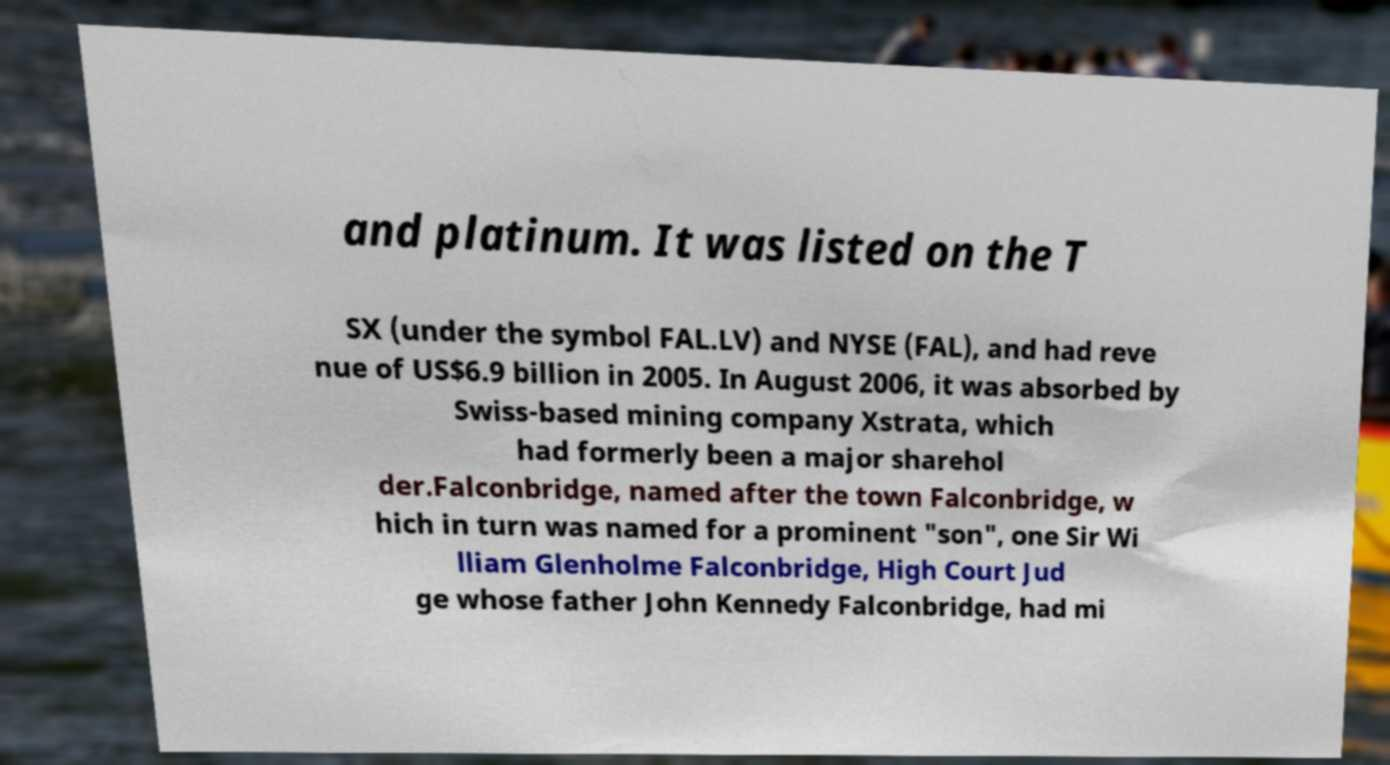Can you read and provide the text displayed in the image?This photo seems to have some interesting text. Can you extract and type it out for me? and platinum. It was listed on the T SX (under the symbol FAL.LV) and NYSE (FAL), and had reve nue of US$6.9 billion in 2005. In August 2006, it was absorbed by Swiss-based mining company Xstrata, which had formerly been a major sharehol der.Falconbridge, named after the town Falconbridge, w hich in turn was named for a prominent "son", one Sir Wi lliam Glenholme Falconbridge, High Court Jud ge whose father John Kennedy Falconbridge, had mi 